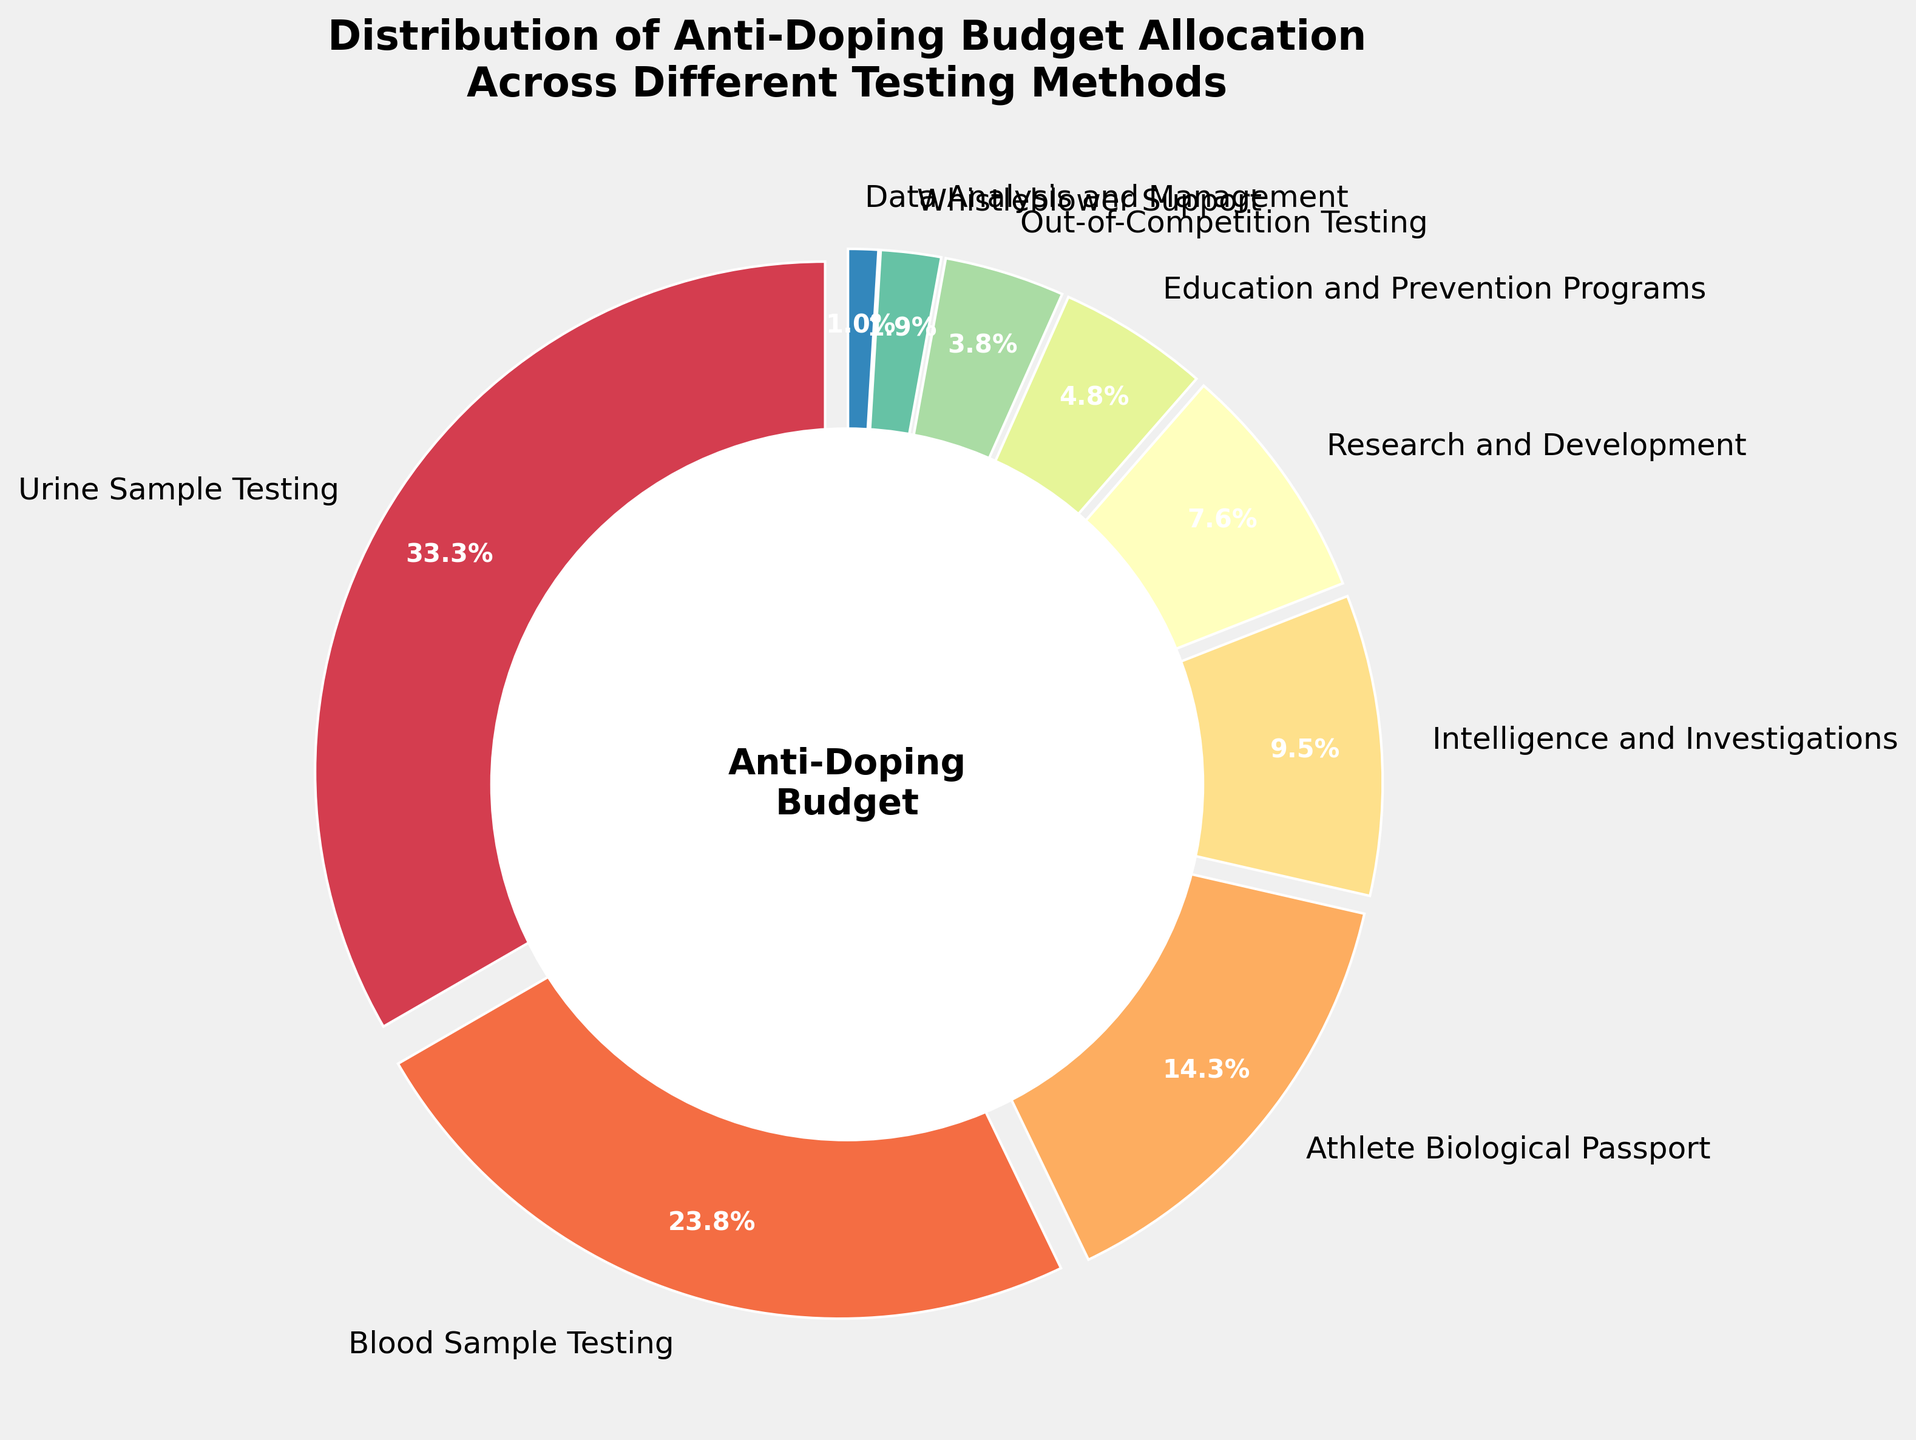What percentage of the budget is allocated to urine sample testing? According to the pie chart, the percentage allocated to urine sample testing is directly given as a label on the chart.
Answer: 35% What is the combined budget allocation for blood sample testing and research and development? Blood sample testing is labeled as 25%, and research and development is labeled as 8%. Adding them together yields 25% + 8% = 33%.
Answer: 33% Which category has the lowest budget allocation, and what is its percentage? The smallest wedge in the pie chart is labeled "Data Analysis and Management" with a percentage of 1%.
Answer: Data Analysis and Management, 1% How much more budget is allocated to athlete biological passport compared to education and prevention programs? The athlete biological passport has 15% of the budget, and education and prevention programs have 5%. Subtracting these yields 15% - 5% = 10%.
Answer: 10% Does out-of-competition testing receive more or less budget than intelligence and investigations? The pie chart shows that intelligence and investigations receive 10% of the budget, while out-of-competition testing receives 4%. Therefore, out-of-competition testing receives less.
Answer: Less How does the budget allocation for urine sample testing compare to blood sample testing? The pie chart indicates that urine sample testing is allocated 35%, while blood sample testing has 25%. Therefore, urine sample testing receives a higher percentage.
Answer: Higher What is the total budget allocation for categories that deal directly with athletes' biological data/testing (Urine Sample Testing, Blood Sample Testing, Athlete Biological Passport)? Combining the percentages for urine sample testing (35%), blood sample testing (25%), and athlete biological passport (15%) gives 35% + 25% + 15% = 75%.
Answer: 75% Which three categories have the highest budget allocations, and what are their percentages? By examining the pie chart, the three largest wedges are for urine sample testing (35%), blood sample testing (25%), and athlete biological passport (15%).
Answer: Urine Sample Testing (35%), Blood Sample Testing (25%), Athlete Biological Passport (15%) Which two categories have budget allocations within 1% of each other, and what are their percentages? Out-of-competition testing (4%) and education and prevention programs (5%) are 1% apart.
Answer: Out-of-Competition Testing (4%), Education and Prevention Programs (5%) What percentage of the budget is allocated to non-testing activities (intelligence and investigations, research and development, education and prevention programs, data analysis and management, whistleblower support)? Summing the percentages of intelligence and investigations (10%), research and development (8%), education and prevention programs (5%), data analysis and management (1%), and whistleblower support (2%) yields 10% + 8% + 5% + 1% + 2% = 26%.
Answer: 26% 